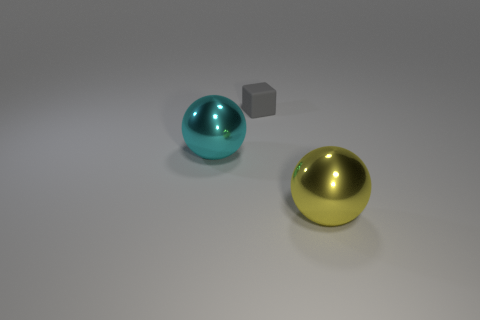There is a object that is left of the gray matte thing; is it the same shape as the large yellow thing?
Provide a short and direct response. Yes. What is the material of the thing that is behind the big ball that is on the left side of the big yellow object?
Ensure brevity in your answer.  Rubber. What is the size of the gray matte block that is behind the large metallic thing that is in front of the big metallic thing on the left side of the gray matte cube?
Make the answer very short. Small. What number of brown balls are made of the same material as the big yellow ball?
Make the answer very short. 0. What is the color of the sphere in front of the shiny sphere to the left of the small gray cube?
Give a very brief answer. Yellow. What number of objects are either big blue cylinders or big metal spheres on the right side of the cyan metallic thing?
Your answer should be very brief. 1. Is there another rubber cube of the same color as the tiny rubber cube?
Provide a short and direct response. No. How many gray things are either metallic balls or large shiny blocks?
Offer a very short reply. 0. How many other things are the same size as the gray rubber thing?
Provide a succinct answer. 0. What number of large objects are matte objects or metallic things?
Give a very brief answer. 2. 